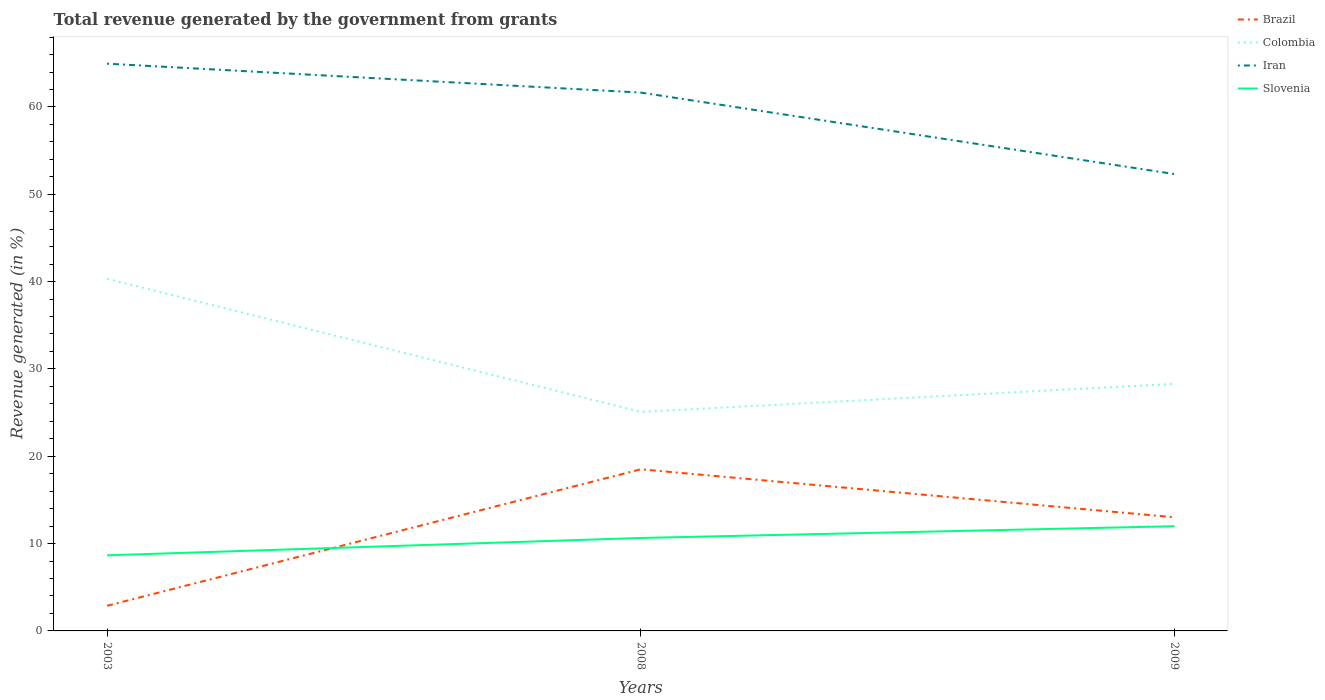How many different coloured lines are there?
Provide a succinct answer. 4. Does the line corresponding to Slovenia intersect with the line corresponding to Colombia?
Ensure brevity in your answer.  No. Is the number of lines equal to the number of legend labels?
Make the answer very short. Yes. Across all years, what is the maximum total revenue generated in Colombia?
Provide a short and direct response. 25.08. What is the total total revenue generated in Iran in the graph?
Give a very brief answer. 12.64. What is the difference between the highest and the second highest total revenue generated in Slovenia?
Provide a short and direct response. 3.33. Is the total revenue generated in Slovenia strictly greater than the total revenue generated in Brazil over the years?
Keep it short and to the point. No. How many lines are there?
Your answer should be very brief. 4. How many years are there in the graph?
Make the answer very short. 3. What is the difference between two consecutive major ticks on the Y-axis?
Give a very brief answer. 10. Are the values on the major ticks of Y-axis written in scientific E-notation?
Offer a very short reply. No. Where does the legend appear in the graph?
Give a very brief answer. Top right. How are the legend labels stacked?
Make the answer very short. Vertical. What is the title of the graph?
Keep it short and to the point. Total revenue generated by the government from grants. What is the label or title of the X-axis?
Give a very brief answer. Years. What is the label or title of the Y-axis?
Offer a terse response. Revenue generated (in %). What is the Revenue generated (in %) of Brazil in 2003?
Keep it short and to the point. 2.88. What is the Revenue generated (in %) in Colombia in 2003?
Offer a terse response. 40.32. What is the Revenue generated (in %) of Iran in 2003?
Keep it short and to the point. 64.95. What is the Revenue generated (in %) of Slovenia in 2003?
Provide a short and direct response. 8.66. What is the Revenue generated (in %) of Brazil in 2008?
Your answer should be very brief. 18.51. What is the Revenue generated (in %) in Colombia in 2008?
Make the answer very short. 25.08. What is the Revenue generated (in %) of Iran in 2008?
Ensure brevity in your answer.  61.64. What is the Revenue generated (in %) of Slovenia in 2008?
Provide a short and direct response. 10.64. What is the Revenue generated (in %) of Brazil in 2009?
Give a very brief answer. 13.01. What is the Revenue generated (in %) in Colombia in 2009?
Provide a succinct answer. 28.29. What is the Revenue generated (in %) of Iran in 2009?
Provide a succinct answer. 52.31. What is the Revenue generated (in %) of Slovenia in 2009?
Your response must be concise. 11.99. Across all years, what is the maximum Revenue generated (in %) in Brazil?
Offer a terse response. 18.51. Across all years, what is the maximum Revenue generated (in %) of Colombia?
Give a very brief answer. 40.32. Across all years, what is the maximum Revenue generated (in %) of Iran?
Provide a short and direct response. 64.95. Across all years, what is the maximum Revenue generated (in %) in Slovenia?
Give a very brief answer. 11.99. Across all years, what is the minimum Revenue generated (in %) in Brazil?
Make the answer very short. 2.88. Across all years, what is the minimum Revenue generated (in %) of Colombia?
Give a very brief answer. 25.08. Across all years, what is the minimum Revenue generated (in %) of Iran?
Offer a terse response. 52.31. Across all years, what is the minimum Revenue generated (in %) in Slovenia?
Give a very brief answer. 8.66. What is the total Revenue generated (in %) in Brazil in the graph?
Your answer should be very brief. 34.4. What is the total Revenue generated (in %) of Colombia in the graph?
Your answer should be compact. 93.7. What is the total Revenue generated (in %) in Iran in the graph?
Make the answer very short. 178.91. What is the total Revenue generated (in %) in Slovenia in the graph?
Make the answer very short. 31.29. What is the difference between the Revenue generated (in %) in Brazil in 2003 and that in 2008?
Give a very brief answer. -15.63. What is the difference between the Revenue generated (in %) of Colombia in 2003 and that in 2008?
Make the answer very short. 15.24. What is the difference between the Revenue generated (in %) of Iran in 2003 and that in 2008?
Your response must be concise. 3.31. What is the difference between the Revenue generated (in %) in Slovenia in 2003 and that in 2008?
Your answer should be compact. -1.99. What is the difference between the Revenue generated (in %) of Brazil in 2003 and that in 2009?
Your response must be concise. -10.13. What is the difference between the Revenue generated (in %) of Colombia in 2003 and that in 2009?
Provide a succinct answer. 12.03. What is the difference between the Revenue generated (in %) in Iran in 2003 and that in 2009?
Keep it short and to the point. 12.64. What is the difference between the Revenue generated (in %) of Slovenia in 2003 and that in 2009?
Keep it short and to the point. -3.33. What is the difference between the Revenue generated (in %) in Brazil in 2008 and that in 2009?
Ensure brevity in your answer.  5.5. What is the difference between the Revenue generated (in %) of Colombia in 2008 and that in 2009?
Give a very brief answer. -3.2. What is the difference between the Revenue generated (in %) of Iran in 2008 and that in 2009?
Make the answer very short. 9.33. What is the difference between the Revenue generated (in %) in Slovenia in 2008 and that in 2009?
Offer a terse response. -1.35. What is the difference between the Revenue generated (in %) in Brazil in 2003 and the Revenue generated (in %) in Colombia in 2008?
Your answer should be very brief. -22.21. What is the difference between the Revenue generated (in %) of Brazil in 2003 and the Revenue generated (in %) of Iran in 2008?
Offer a terse response. -58.77. What is the difference between the Revenue generated (in %) in Brazil in 2003 and the Revenue generated (in %) in Slovenia in 2008?
Provide a succinct answer. -7.77. What is the difference between the Revenue generated (in %) in Colombia in 2003 and the Revenue generated (in %) in Iran in 2008?
Provide a short and direct response. -21.32. What is the difference between the Revenue generated (in %) in Colombia in 2003 and the Revenue generated (in %) in Slovenia in 2008?
Your answer should be very brief. 29.68. What is the difference between the Revenue generated (in %) in Iran in 2003 and the Revenue generated (in %) in Slovenia in 2008?
Keep it short and to the point. 54.31. What is the difference between the Revenue generated (in %) in Brazil in 2003 and the Revenue generated (in %) in Colombia in 2009?
Your answer should be compact. -25.41. What is the difference between the Revenue generated (in %) of Brazil in 2003 and the Revenue generated (in %) of Iran in 2009?
Your answer should be very brief. -49.44. What is the difference between the Revenue generated (in %) in Brazil in 2003 and the Revenue generated (in %) in Slovenia in 2009?
Provide a short and direct response. -9.11. What is the difference between the Revenue generated (in %) of Colombia in 2003 and the Revenue generated (in %) of Iran in 2009?
Make the answer very short. -11.99. What is the difference between the Revenue generated (in %) of Colombia in 2003 and the Revenue generated (in %) of Slovenia in 2009?
Provide a succinct answer. 28.33. What is the difference between the Revenue generated (in %) of Iran in 2003 and the Revenue generated (in %) of Slovenia in 2009?
Offer a very short reply. 52.96. What is the difference between the Revenue generated (in %) in Brazil in 2008 and the Revenue generated (in %) in Colombia in 2009?
Ensure brevity in your answer.  -9.78. What is the difference between the Revenue generated (in %) in Brazil in 2008 and the Revenue generated (in %) in Iran in 2009?
Provide a succinct answer. -33.81. What is the difference between the Revenue generated (in %) in Brazil in 2008 and the Revenue generated (in %) in Slovenia in 2009?
Your response must be concise. 6.52. What is the difference between the Revenue generated (in %) of Colombia in 2008 and the Revenue generated (in %) of Iran in 2009?
Offer a terse response. -27.23. What is the difference between the Revenue generated (in %) in Colombia in 2008 and the Revenue generated (in %) in Slovenia in 2009?
Offer a very short reply. 13.09. What is the difference between the Revenue generated (in %) of Iran in 2008 and the Revenue generated (in %) of Slovenia in 2009?
Provide a succinct answer. 49.65. What is the average Revenue generated (in %) of Brazil per year?
Give a very brief answer. 11.47. What is the average Revenue generated (in %) in Colombia per year?
Your answer should be very brief. 31.23. What is the average Revenue generated (in %) of Iran per year?
Give a very brief answer. 59.64. What is the average Revenue generated (in %) of Slovenia per year?
Offer a very short reply. 10.43. In the year 2003, what is the difference between the Revenue generated (in %) of Brazil and Revenue generated (in %) of Colombia?
Keep it short and to the point. -37.44. In the year 2003, what is the difference between the Revenue generated (in %) in Brazil and Revenue generated (in %) in Iran?
Your response must be concise. -62.08. In the year 2003, what is the difference between the Revenue generated (in %) of Brazil and Revenue generated (in %) of Slovenia?
Your answer should be very brief. -5.78. In the year 2003, what is the difference between the Revenue generated (in %) in Colombia and Revenue generated (in %) in Iran?
Your answer should be compact. -24.63. In the year 2003, what is the difference between the Revenue generated (in %) in Colombia and Revenue generated (in %) in Slovenia?
Provide a succinct answer. 31.67. In the year 2003, what is the difference between the Revenue generated (in %) of Iran and Revenue generated (in %) of Slovenia?
Provide a succinct answer. 56.3. In the year 2008, what is the difference between the Revenue generated (in %) in Brazil and Revenue generated (in %) in Colombia?
Provide a short and direct response. -6.58. In the year 2008, what is the difference between the Revenue generated (in %) of Brazil and Revenue generated (in %) of Iran?
Offer a very short reply. -43.14. In the year 2008, what is the difference between the Revenue generated (in %) in Brazil and Revenue generated (in %) in Slovenia?
Provide a short and direct response. 7.86. In the year 2008, what is the difference between the Revenue generated (in %) of Colombia and Revenue generated (in %) of Iran?
Provide a short and direct response. -36.56. In the year 2008, what is the difference between the Revenue generated (in %) of Colombia and Revenue generated (in %) of Slovenia?
Provide a short and direct response. 14.44. In the year 2008, what is the difference between the Revenue generated (in %) of Iran and Revenue generated (in %) of Slovenia?
Provide a succinct answer. 51. In the year 2009, what is the difference between the Revenue generated (in %) of Brazil and Revenue generated (in %) of Colombia?
Your answer should be very brief. -15.28. In the year 2009, what is the difference between the Revenue generated (in %) in Brazil and Revenue generated (in %) in Iran?
Your answer should be compact. -39.3. In the year 2009, what is the difference between the Revenue generated (in %) of Brazil and Revenue generated (in %) of Slovenia?
Provide a succinct answer. 1.02. In the year 2009, what is the difference between the Revenue generated (in %) in Colombia and Revenue generated (in %) in Iran?
Offer a very short reply. -24.03. In the year 2009, what is the difference between the Revenue generated (in %) of Colombia and Revenue generated (in %) of Slovenia?
Provide a short and direct response. 16.3. In the year 2009, what is the difference between the Revenue generated (in %) of Iran and Revenue generated (in %) of Slovenia?
Provide a succinct answer. 40.32. What is the ratio of the Revenue generated (in %) of Brazil in 2003 to that in 2008?
Keep it short and to the point. 0.16. What is the ratio of the Revenue generated (in %) in Colombia in 2003 to that in 2008?
Offer a terse response. 1.61. What is the ratio of the Revenue generated (in %) of Iran in 2003 to that in 2008?
Provide a short and direct response. 1.05. What is the ratio of the Revenue generated (in %) of Slovenia in 2003 to that in 2008?
Your answer should be compact. 0.81. What is the ratio of the Revenue generated (in %) of Brazil in 2003 to that in 2009?
Offer a very short reply. 0.22. What is the ratio of the Revenue generated (in %) in Colombia in 2003 to that in 2009?
Make the answer very short. 1.43. What is the ratio of the Revenue generated (in %) in Iran in 2003 to that in 2009?
Provide a succinct answer. 1.24. What is the ratio of the Revenue generated (in %) in Slovenia in 2003 to that in 2009?
Offer a very short reply. 0.72. What is the ratio of the Revenue generated (in %) of Brazil in 2008 to that in 2009?
Keep it short and to the point. 1.42. What is the ratio of the Revenue generated (in %) in Colombia in 2008 to that in 2009?
Make the answer very short. 0.89. What is the ratio of the Revenue generated (in %) in Iran in 2008 to that in 2009?
Ensure brevity in your answer.  1.18. What is the ratio of the Revenue generated (in %) in Slovenia in 2008 to that in 2009?
Give a very brief answer. 0.89. What is the difference between the highest and the second highest Revenue generated (in %) in Brazil?
Make the answer very short. 5.5. What is the difference between the highest and the second highest Revenue generated (in %) of Colombia?
Your answer should be very brief. 12.03. What is the difference between the highest and the second highest Revenue generated (in %) in Iran?
Your response must be concise. 3.31. What is the difference between the highest and the second highest Revenue generated (in %) in Slovenia?
Your answer should be compact. 1.35. What is the difference between the highest and the lowest Revenue generated (in %) in Brazil?
Provide a succinct answer. 15.63. What is the difference between the highest and the lowest Revenue generated (in %) of Colombia?
Ensure brevity in your answer.  15.24. What is the difference between the highest and the lowest Revenue generated (in %) in Iran?
Provide a short and direct response. 12.64. What is the difference between the highest and the lowest Revenue generated (in %) in Slovenia?
Ensure brevity in your answer.  3.33. 